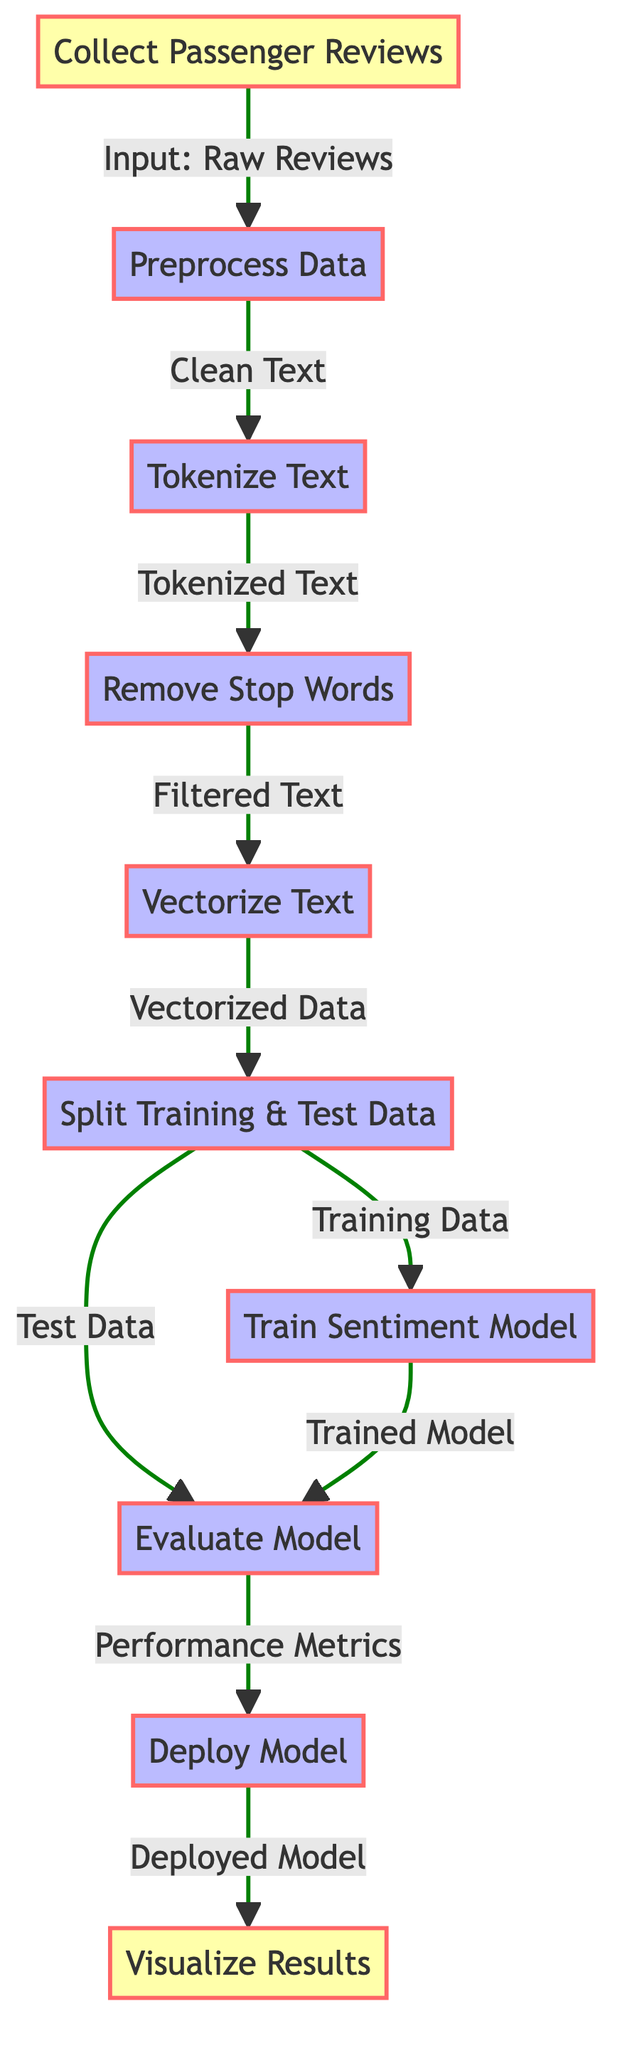What is the first step in the diagram? The diagram starts with the node labeled "Collect Passenger Reviews," which indicates the initial action of gathering data.
Answer: Collect Passenger Reviews How many main process nodes are there in the diagram? The process nodes in the diagram are: "Preprocess Data," "Tokenize Text," "Remove Stop Words," "Vectorize Text," "Train Sentiment Model," "Split Training & Test Data," "Evaluate Model," and "Deploy Model." This totals to seven main process nodes.
Answer: Seven Which node comes after "Evaluate Model"? According to the flow in the diagram, the next node after "Evaluate Model" is "Deploy Model."
Answer: Deploy Model What type of data is generated from the "Vectorize Text" node? The "Vectorize Text" node produces "Vectorized Data" as its output, which signifies the processed representation of the text.
Answer: Vectorized Data Which two nodes receive input from the "Split Training & Test Data" node? The "Split Training & Test Data" node branches into "Train Sentiment Model" and "Evaluate Model," indicating that both nodes depend on the output from the previous step.
Answer: Train Sentiment Model and Evaluate Model What output does the "Deploy Model" node produce? The output of the "Deploy Model" node is labeled "Deployed Model," which signifies that the trained model is now ready for use.
Answer: Deployed Model If the input is raw reviews, what is the final output after passing through all steps? The entire flow in the diagram, starting from "Collect Passenger Reviews" and moving through all nodes, ultimately leads to the "Visualize Results" node as the final output, indicating the visual representation of the processed reviews.
Answer: Visualize Results What is the relationship between "Train Sentiment Model" and "Evaluate Model"? The relationship is that both nodes receive input from the "Split Training & Test Data" node, which indicates that the training and evaluation processes are parallel steps following data preparation.
Answer: Parallel steps What is the role of the "Remove Stop Words" node in the process? The "Remove Stop Words" node filters unnecessary common words from the tokenized text, which helps in reducing noise and improving the quality of the input for the next steps.
Answer: Filtered Text 